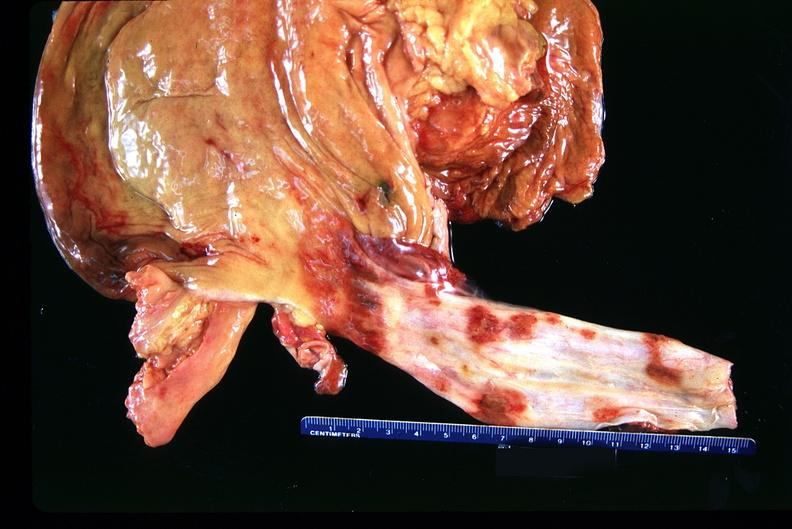s gastrointestinal present?
Answer the question using a single word or phrase. Yes 